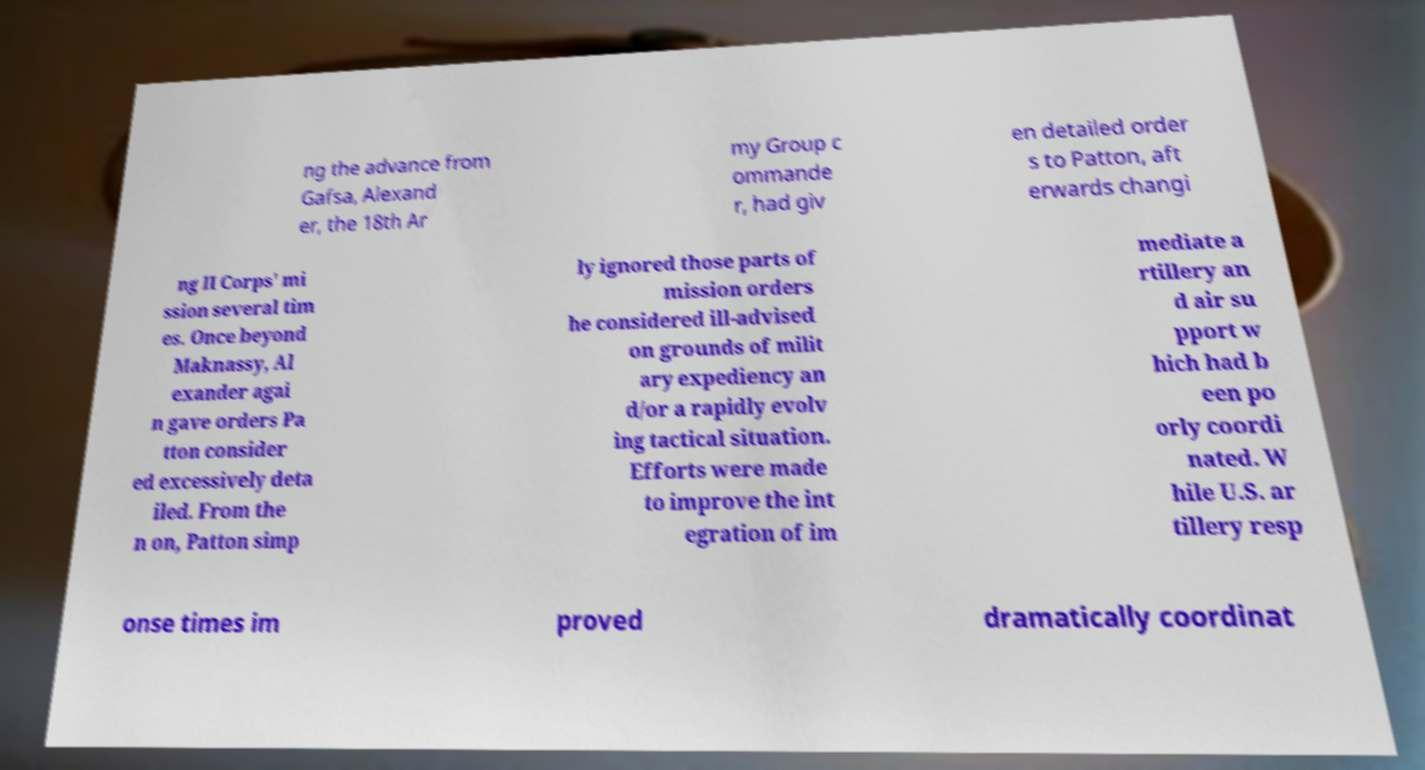Please read and relay the text visible in this image. What does it say? ng the advance from Gafsa, Alexand er, the 18th Ar my Group c ommande r, had giv en detailed order s to Patton, aft erwards changi ng II Corps' mi ssion several tim es. Once beyond Maknassy, Al exander agai n gave orders Pa tton consider ed excessively deta iled. From the n on, Patton simp ly ignored those parts of mission orders he considered ill-advised on grounds of milit ary expediency an d/or a rapidly evolv ing tactical situation. Efforts were made to improve the int egration of im mediate a rtillery an d air su pport w hich had b een po orly coordi nated. W hile U.S. ar tillery resp onse times im proved dramatically coordinat 